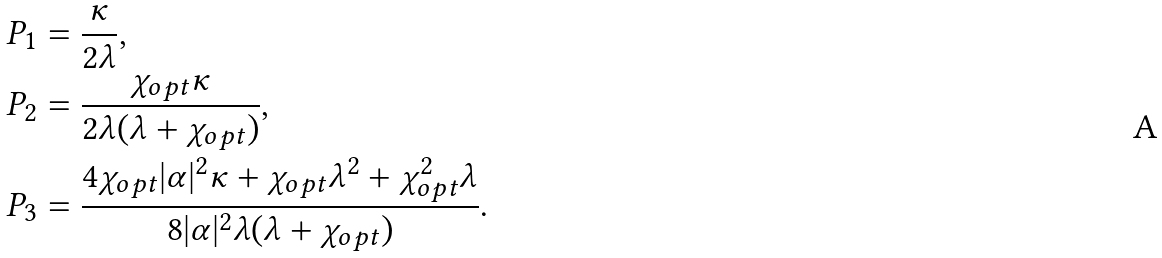<formula> <loc_0><loc_0><loc_500><loc_500>P _ { 1 } & = \frac { \kappa } { 2 \lambda } , \\ P _ { 2 } & = \frac { \chi _ { o p t } \kappa } { 2 \lambda ( \lambda + \chi _ { o p t } ) } , \\ P _ { 3 } & = \frac { 4 \chi _ { o p t } | \alpha | ^ { 2 } \kappa + \chi _ { o p t } \lambda ^ { 2 } + \chi _ { o p t } ^ { 2 } \lambda } { 8 | \alpha | ^ { 2 } \lambda ( \lambda + \chi _ { o p t } ) } .</formula> 